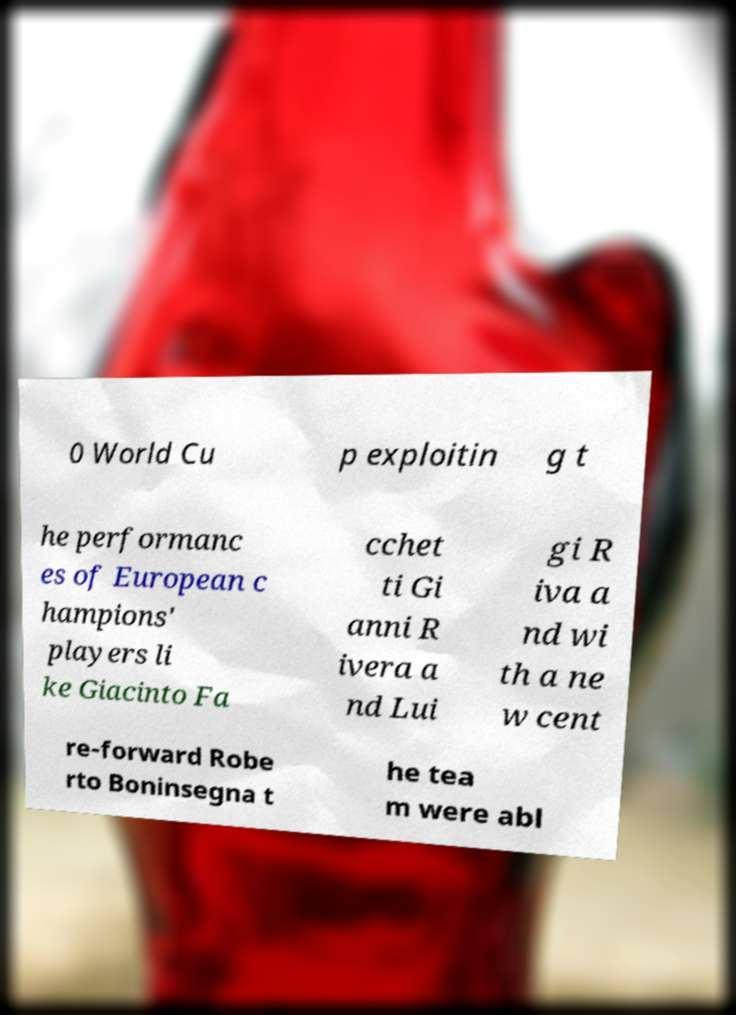Could you extract and type out the text from this image? 0 World Cu p exploitin g t he performanc es of European c hampions' players li ke Giacinto Fa cchet ti Gi anni R ivera a nd Lui gi R iva a nd wi th a ne w cent re-forward Robe rto Boninsegna t he tea m were abl 